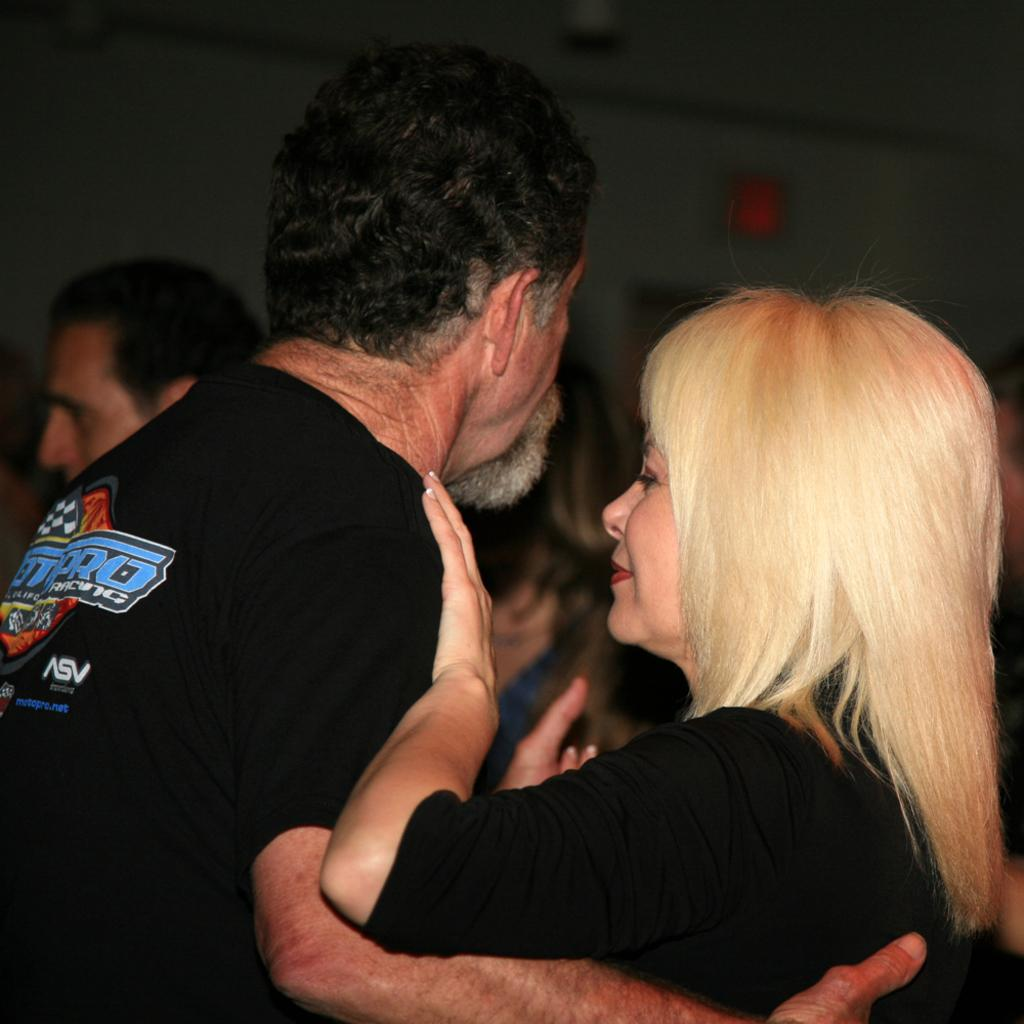<image>
Describe the image concisely. a man and a lady embracing with the man wearing a racing shirt 